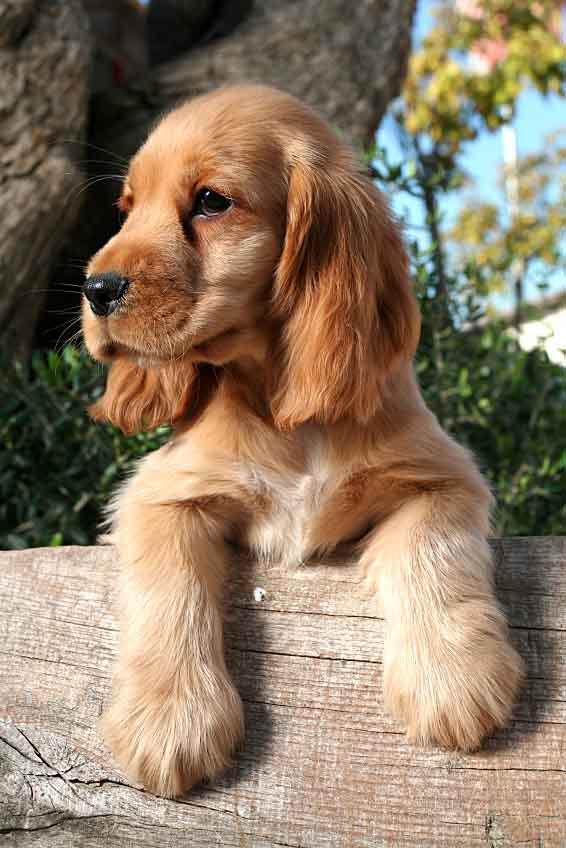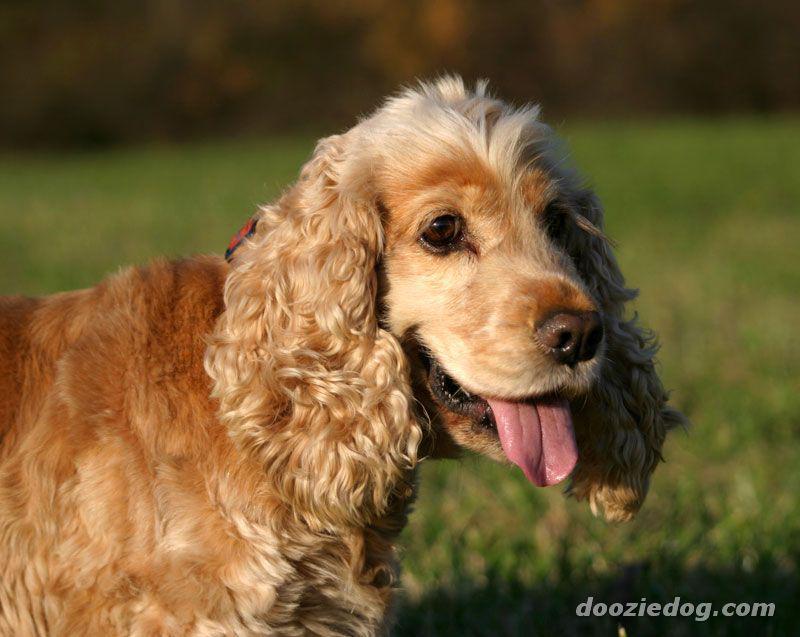The first image is the image on the left, the second image is the image on the right. Considering the images on both sides, is "The right image contains exactly two dogs." valid? Answer yes or no. No. The first image is the image on the left, the second image is the image on the right. Assess this claim about the two images: "An image includes at least three dogs of different colors.". Correct or not? Answer yes or no. No. 